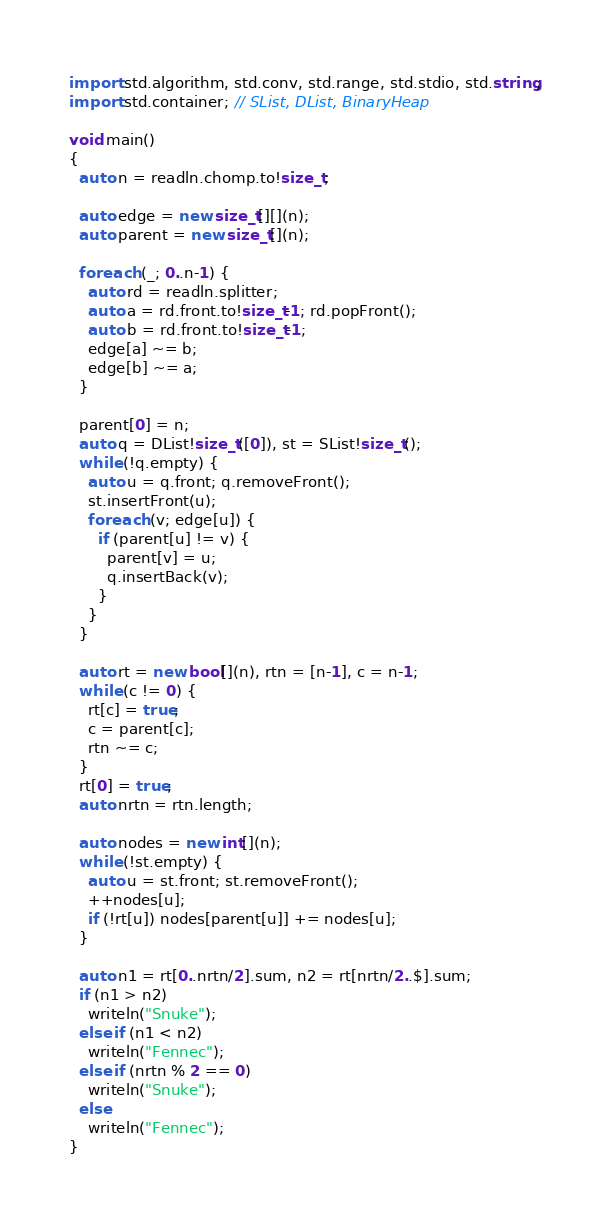Convert code to text. <code><loc_0><loc_0><loc_500><loc_500><_D_>import std.algorithm, std.conv, std.range, std.stdio, std.string;
import std.container; // SList, DList, BinaryHeap

void main()
{
  auto n = readln.chomp.to!size_t;

  auto edge = new size_t[][](n);
  auto parent = new size_t[](n);

  foreach (_; 0..n-1) {
    auto rd = readln.splitter;
    auto a = rd.front.to!size_t-1; rd.popFront();
    auto b = rd.front.to!size_t-1;
    edge[a] ~= b;
    edge[b] ~= a;
  }

  parent[0] = n;
  auto q = DList!size_t([0]), st = SList!size_t();
  while (!q.empty) {
    auto u = q.front; q.removeFront();
    st.insertFront(u);
    foreach (v; edge[u]) {
      if (parent[u] != v) {
        parent[v] = u;
        q.insertBack(v);
      }
    }
  }

  auto rt = new bool[](n), rtn = [n-1], c = n-1;
  while (c != 0) {
    rt[c] = true;
    c = parent[c];
    rtn ~= c;
  }
  rt[0] = true;
  auto nrtn = rtn.length;

  auto nodes = new int[](n);
  while (!st.empty) {
    auto u = st.front; st.removeFront();
    ++nodes[u];
    if (!rt[u]) nodes[parent[u]] += nodes[u];
  }

  auto n1 = rt[0..nrtn/2].sum, n2 = rt[nrtn/2..$].sum;
  if (n1 > n2)
    writeln("Snuke");
  else if (n1 < n2)
    writeln("Fennec");
  else if (nrtn % 2 == 0)
    writeln("Snuke");
  else
    writeln("Fennec");
}
</code> 